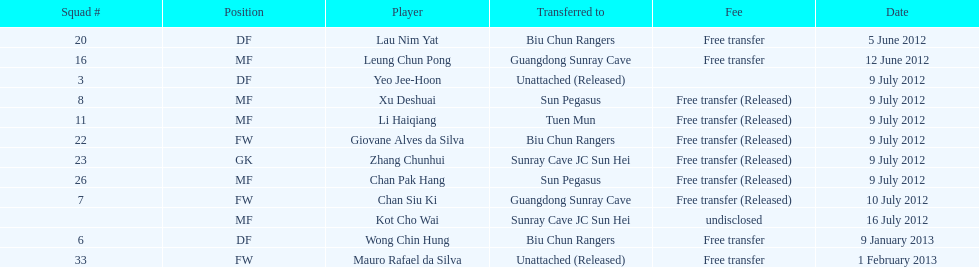What unit # comes preceding unit # 7? 26. 